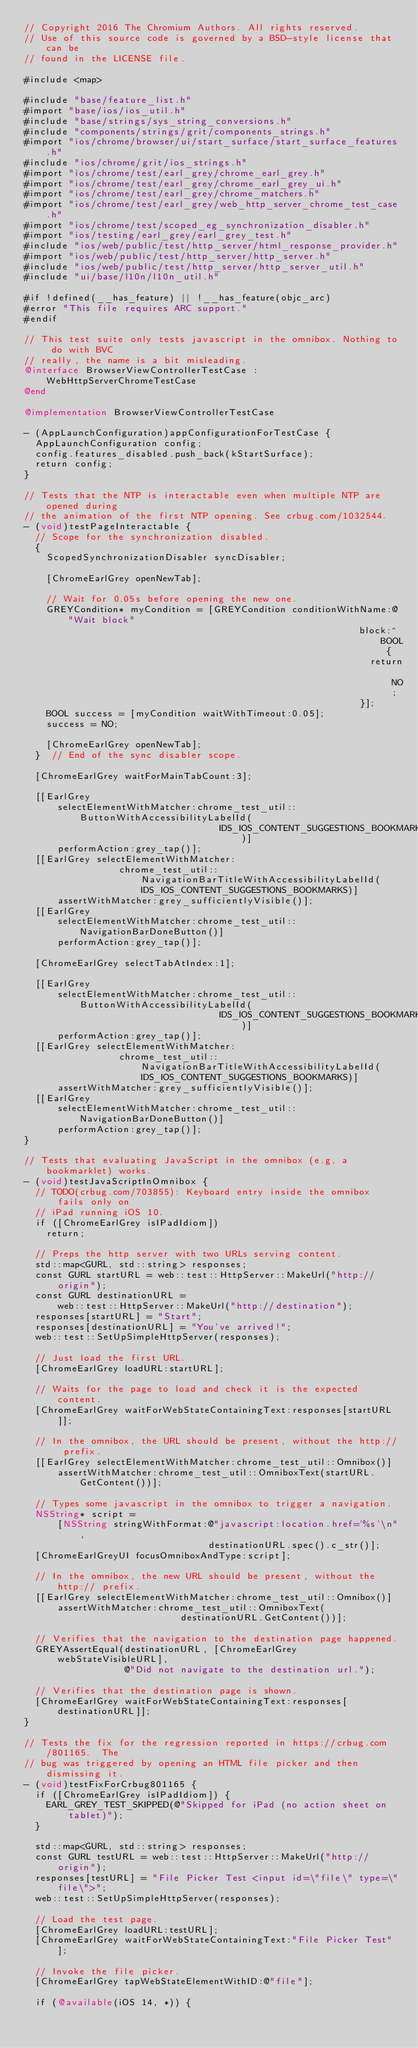Convert code to text. <code><loc_0><loc_0><loc_500><loc_500><_ObjectiveC_>// Copyright 2016 The Chromium Authors. All rights reserved.
// Use of this source code is governed by a BSD-style license that can be
// found in the LICENSE file.

#include <map>

#include "base/feature_list.h"
#import "base/ios/ios_util.h"
#include "base/strings/sys_string_conversions.h"
#include "components/strings/grit/components_strings.h"
#import "ios/chrome/browser/ui/start_surface/start_surface_features.h"
#include "ios/chrome/grit/ios_strings.h"
#import "ios/chrome/test/earl_grey/chrome_earl_grey.h"
#import "ios/chrome/test/earl_grey/chrome_earl_grey_ui.h"
#import "ios/chrome/test/earl_grey/chrome_matchers.h"
#import "ios/chrome/test/earl_grey/web_http_server_chrome_test_case.h"
#import "ios/chrome/test/scoped_eg_synchronization_disabler.h"
#import "ios/testing/earl_grey/earl_grey_test.h"
#include "ios/web/public/test/http_server/html_response_provider.h"
#import "ios/web/public/test/http_server/http_server.h"
#include "ios/web/public/test/http_server/http_server_util.h"
#include "ui/base/l10n/l10n_util.h"

#if !defined(__has_feature) || !__has_feature(objc_arc)
#error "This file requires ARC support."
#endif

// This test suite only tests javascript in the omnibox. Nothing to do with BVC
// really, the name is a bit misleading.
@interface BrowserViewControllerTestCase : WebHttpServerChromeTestCase
@end

@implementation BrowserViewControllerTestCase

- (AppLaunchConfiguration)appConfigurationForTestCase {
  AppLaunchConfiguration config;
  config.features_disabled.push_back(kStartSurface);
  return config;
}

// Tests that the NTP is interactable even when multiple NTP are opened during
// the animation of the first NTP opening. See crbug.com/1032544.
- (void)testPageInteractable {
  // Scope for the synchronization disabled.
  {
    ScopedSynchronizationDisabler syncDisabler;

    [ChromeEarlGrey openNewTab];

    // Wait for 0.05s before opening the new one.
    GREYCondition* myCondition = [GREYCondition conditionWithName:@"Wait block"
                                                            block:^BOOL {
                                                              return NO;
                                                            }];
    BOOL success = [myCondition waitWithTimeout:0.05];
    success = NO;

    [ChromeEarlGrey openNewTab];
  }  // End of the sync disabler scope.

  [ChromeEarlGrey waitForMainTabCount:3];

  [[EarlGrey
      selectElementWithMatcher:chrome_test_util::ButtonWithAccessibilityLabelId(
                                   IDS_IOS_CONTENT_SUGGESTIONS_BOOKMARKS)]
      performAction:grey_tap()];
  [[EarlGrey selectElementWithMatcher:
                 chrome_test_util::NavigationBarTitleWithAccessibilityLabelId(
                     IDS_IOS_CONTENT_SUGGESTIONS_BOOKMARKS)]
      assertWithMatcher:grey_sufficientlyVisible()];
  [[EarlGrey
      selectElementWithMatcher:chrome_test_util::NavigationBarDoneButton()]
      performAction:grey_tap()];

  [ChromeEarlGrey selectTabAtIndex:1];

  [[EarlGrey
      selectElementWithMatcher:chrome_test_util::ButtonWithAccessibilityLabelId(
                                   IDS_IOS_CONTENT_SUGGESTIONS_BOOKMARKS)]
      performAction:grey_tap()];
  [[EarlGrey selectElementWithMatcher:
                 chrome_test_util::NavigationBarTitleWithAccessibilityLabelId(
                     IDS_IOS_CONTENT_SUGGESTIONS_BOOKMARKS)]
      assertWithMatcher:grey_sufficientlyVisible()];
  [[EarlGrey
      selectElementWithMatcher:chrome_test_util::NavigationBarDoneButton()]
      performAction:grey_tap()];
}

// Tests that evaluating JavaScript in the omnibox (e.g, a bookmarklet) works.
- (void)testJavaScriptInOmnibox {
  // TODO(crbug.com/703855): Keyboard entry inside the omnibox fails only on
  // iPad running iOS 10.
  if ([ChromeEarlGrey isIPadIdiom])
    return;

  // Preps the http server with two URLs serving content.
  std::map<GURL, std::string> responses;
  const GURL startURL = web::test::HttpServer::MakeUrl("http://origin");
  const GURL destinationURL =
      web::test::HttpServer::MakeUrl("http://destination");
  responses[startURL] = "Start";
  responses[destinationURL] = "You've arrived!";
  web::test::SetUpSimpleHttpServer(responses);

  // Just load the first URL.
  [ChromeEarlGrey loadURL:startURL];

  // Waits for the page to load and check it is the expected content.
  [ChromeEarlGrey waitForWebStateContainingText:responses[startURL]];

  // In the omnibox, the URL should be present, without the http:// prefix.
  [[EarlGrey selectElementWithMatcher:chrome_test_util::Omnibox()]
      assertWithMatcher:chrome_test_util::OmniboxText(startURL.GetContent())];

  // Types some javascript in the omnibox to trigger a navigation.
  NSString* script =
      [NSString stringWithFormat:@"javascript:location.href='%s'\n",
                                 destinationURL.spec().c_str()];
  [ChromeEarlGreyUI focusOmniboxAndType:script];

  // In the omnibox, the new URL should be present, without the http:// prefix.
  [[EarlGrey selectElementWithMatcher:chrome_test_util::Omnibox()]
      assertWithMatcher:chrome_test_util::OmniboxText(
                            destinationURL.GetContent())];

  // Verifies that the navigation to the destination page happened.
  GREYAssertEqual(destinationURL, [ChromeEarlGrey webStateVisibleURL],
                  @"Did not navigate to the destination url.");

  // Verifies that the destination page is shown.
  [ChromeEarlGrey waitForWebStateContainingText:responses[destinationURL]];
}

// Tests the fix for the regression reported in https://crbug.com/801165.  The
// bug was triggered by opening an HTML file picker and then dismissing it.
- (void)testFixForCrbug801165 {
  if ([ChromeEarlGrey isIPadIdiom]) {
    EARL_GREY_TEST_SKIPPED(@"Skipped for iPad (no action sheet on tablet)");
  }

  std::map<GURL, std::string> responses;
  const GURL testURL = web::test::HttpServer::MakeUrl("http://origin");
  responses[testURL] = "File Picker Test <input id=\"file\" type=\"file\">";
  web::test::SetUpSimpleHttpServer(responses);

  // Load the test page.
  [ChromeEarlGrey loadURL:testURL];
  [ChromeEarlGrey waitForWebStateContainingText:"File Picker Test"];

  // Invoke the file picker.
  [ChromeEarlGrey tapWebStateElementWithID:@"file"];

  if (@available(iOS 14, *)) {</code> 